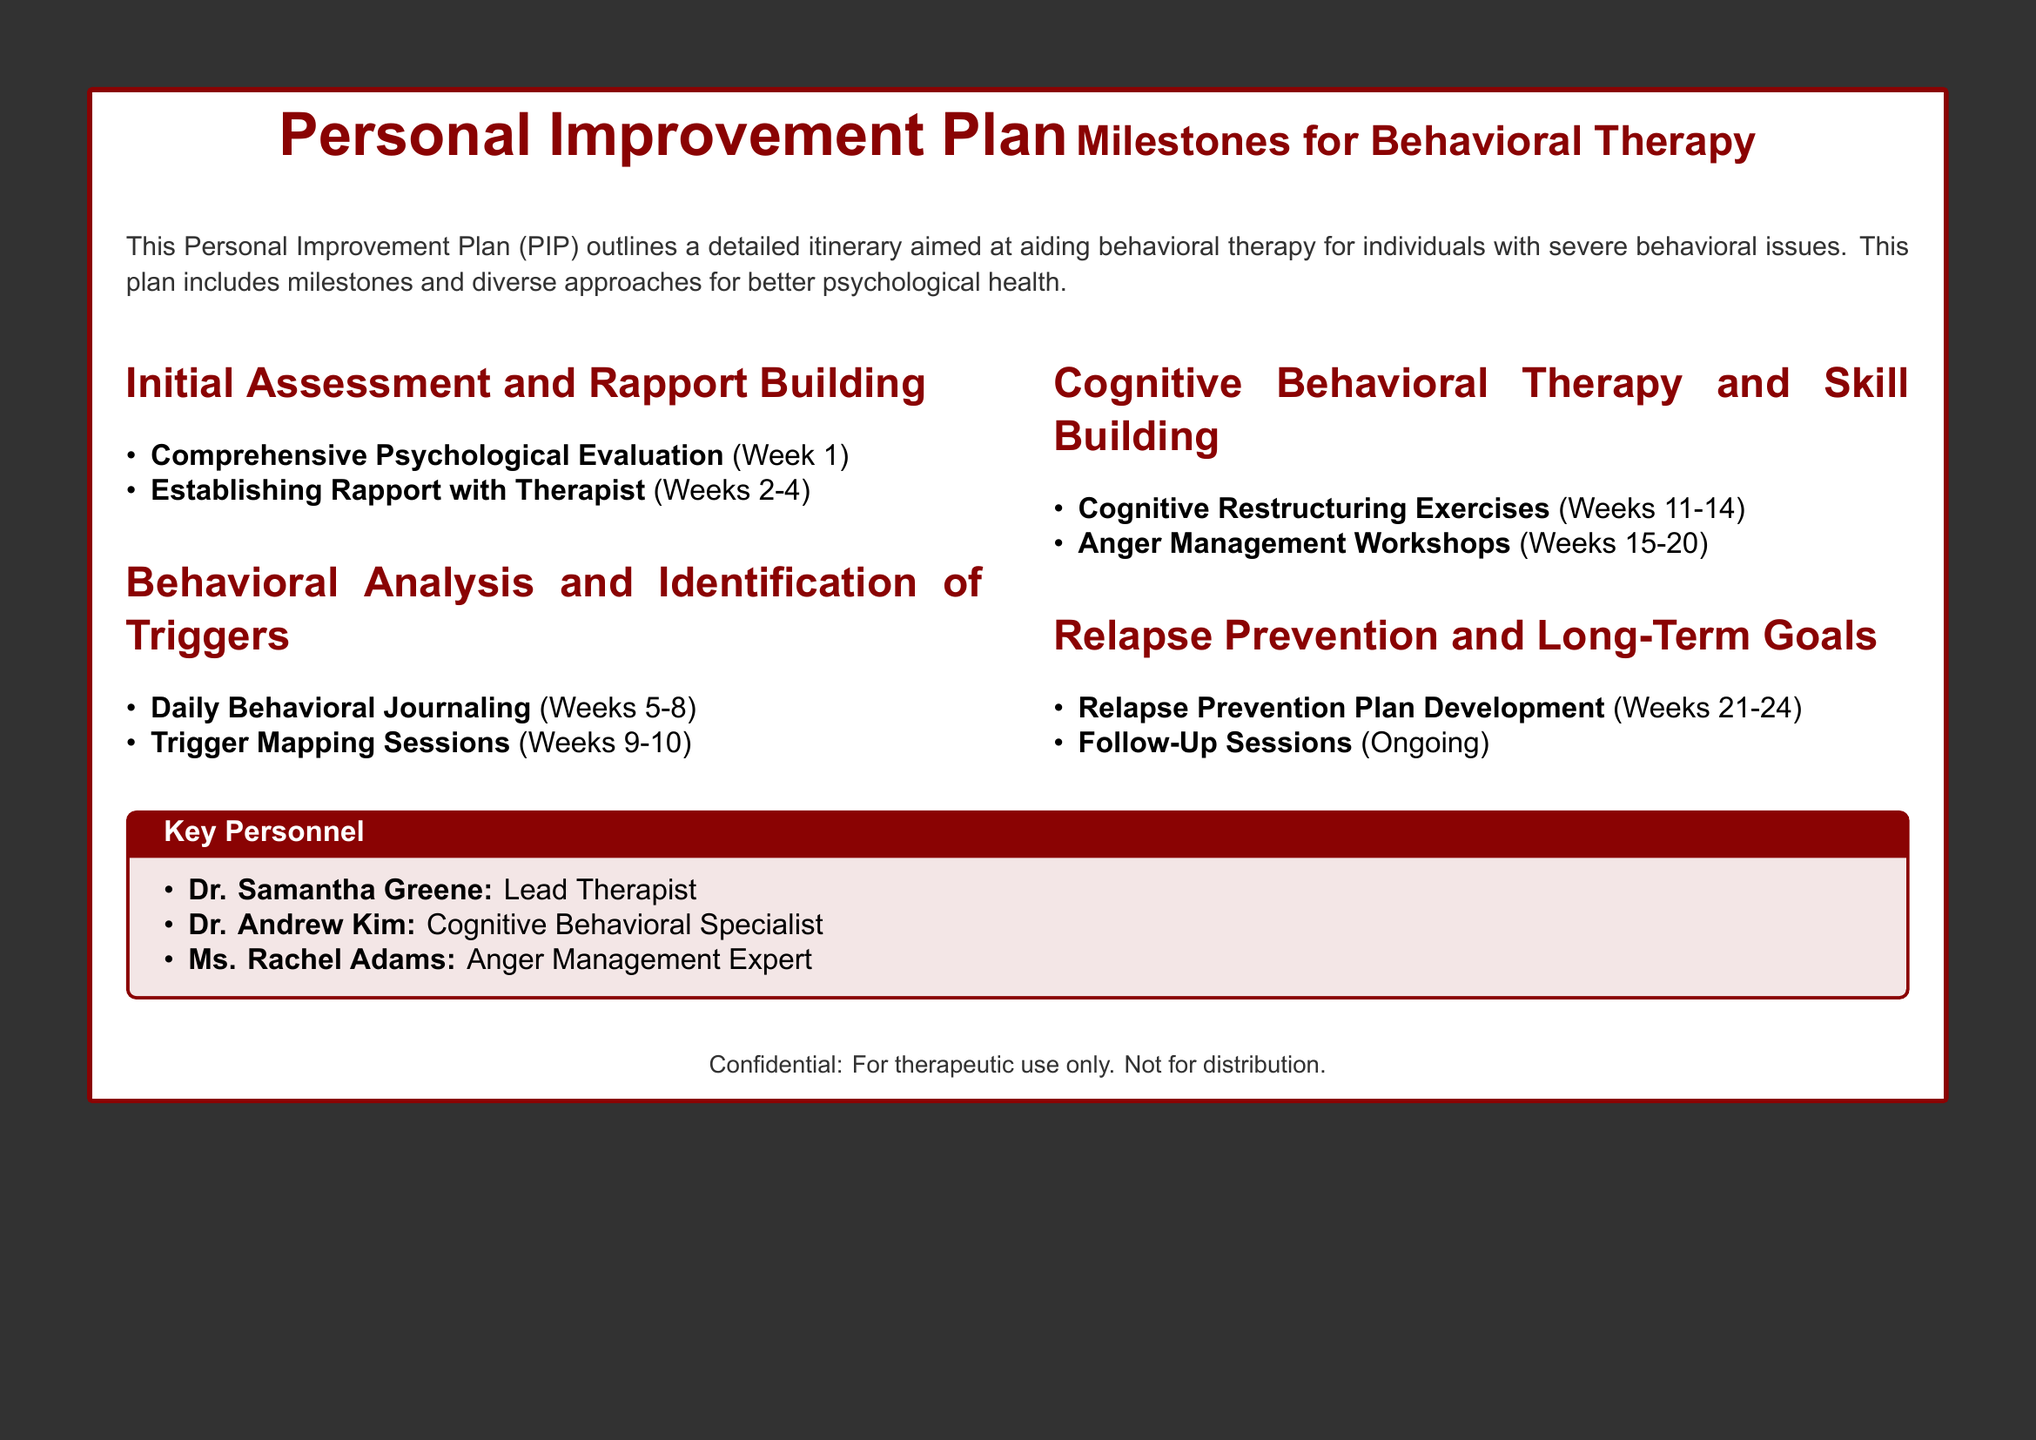What is the title of the document? The title of the document is located at the top and is stated in a large font.
Answer: Personal Improvement Plan Who is the lead therapist? The document lists key personnel involved in the plan, including their roles.
Answer: Dr. Samantha Greene What is the duration of the anger management workshops? The anger management workshops duration is specified in the behavioral therapy plan.
Answer: Weeks 15-20 How many weeks are allocated for establishing rapport with the therapist? The number of weeks for this phase is stated clearly in the itinerary.
Answer: Weeks 2-4 What type of sessions occur during Weeks 9 to 10? These sessions are key components of the behavioral analysis phase in the plan.
Answer: Trigger Mapping Sessions What is the purpose of the daily behavioral journaling? This activity is part of identifying triggers and understanding behavior.
Answer: Behavioral Analysis How many experts are listed in the key personnel section? The key personnel section provides specific roles and the corresponding number of individuals.
Answer: Three What document feature indicates confidentiality? The document has a specific footnote indicating its confidentiality status.
Answer: Confidential: For therapeutic use only. Not for distribution What phase follows cognitive restructuring exercises? The plan outlines subsequent phases of the behavioral therapy approach.
Answer: Anger Management Workshops 